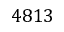Convert formula to latex. <formula><loc_0><loc_0><loc_500><loc_500>4 8 1 3</formula> 